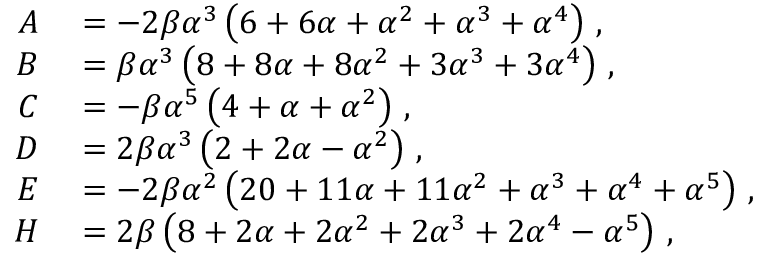<formula> <loc_0><loc_0><loc_500><loc_500>\begin{array} { r l } { A } & = - 2 \beta \alpha ^ { 3 } \left ( 6 + 6 \alpha + \alpha ^ { 2 } + \alpha ^ { 3 } + \alpha ^ { 4 } \right ) \, , } \\ { B } & = \beta \alpha ^ { 3 } \left ( 8 + 8 \alpha + 8 \alpha ^ { 2 } + 3 \alpha ^ { 3 } + 3 \alpha ^ { 4 } \right ) \, , } \\ { C } & = - \beta \alpha ^ { 5 } \left ( 4 + \alpha + \alpha ^ { 2 } \right ) \, , } \\ { D } & = 2 \beta \alpha ^ { 3 } \left ( 2 + 2 \alpha - \alpha ^ { 2 } \right ) \, , } \\ { E } & = - 2 \beta \alpha ^ { 2 } \left ( 2 0 + 1 1 \alpha + 1 1 \alpha ^ { 2 } + \alpha ^ { 3 } + \alpha ^ { 4 } + \alpha ^ { 5 } \right ) \, , } \\ { H } & = 2 \beta \left ( 8 + 2 \alpha + 2 \alpha ^ { 2 } + 2 \alpha ^ { 3 } + 2 \alpha ^ { 4 } - \alpha ^ { 5 } \right ) \, , } \end{array}</formula> 